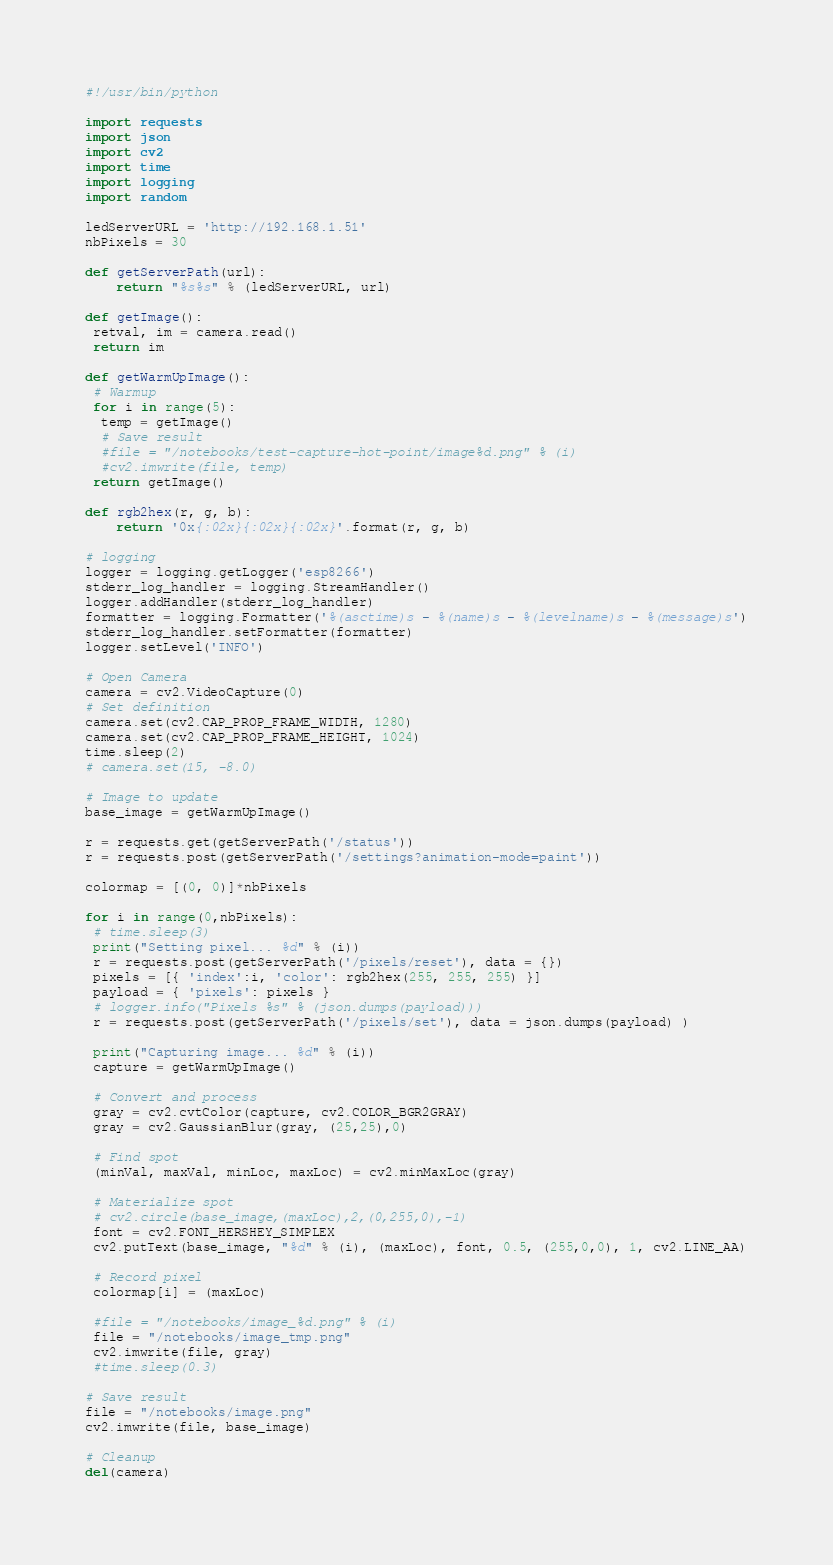<code> <loc_0><loc_0><loc_500><loc_500><_Python_>#!/usr/bin/python

import requests
import json
import cv2
import time
import logging
import random

ledServerURL = 'http://192.168.1.51'
nbPixels = 30

def getServerPath(url):
    return "%s%s" % (ledServerURL, url)

def getImage():
 retval, im = camera.read()
 return im

def getWarmUpImage():
 # Warmup
 for i in range(5):
  temp = getImage()
  # Save result
  #file = "/notebooks/test-capture-hot-point/image%d.png" % (i)
  #cv2.imwrite(file, temp)
 return getImage()

def rgb2hex(r, g, b):
    return '0x{:02x}{:02x}{:02x}'.format(r, g, b)

# logging
logger = logging.getLogger('esp8266')
stderr_log_handler = logging.StreamHandler()
logger.addHandler(stderr_log_handler)
formatter = logging.Formatter('%(asctime)s - %(name)s - %(levelname)s - %(message)s')
stderr_log_handler.setFormatter(formatter)
logger.setLevel('INFO')

# Open Camera
camera = cv2.VideoCapture(0)
# Set definition
camera.set(cv2.CAP_PROP_FRAME_WIDTH, 1280)
camera.set(cv2.CAP_PROP_FRAME_HEIGHT, 1024)
time.sleep(2)
# camera.set(15, -8.0)

# Image to update
base_image = getWarmUpImage()

r = requests.get(getServerPath('/status'))
r = requests.post(getServerPath('/settings?animation-mode=paint'))

colormap = [(0, 0)]*nbPixels

for i in range(0,nbPixels):
 # time.sleep(3)
 print("Setting pixel... %d" % (i))
 r = requests.post(getServerPath('/pixels/reset'), data = {})
 pixels = [{ 'index':i, 'color': rgb2hex(255, 255, 255) }]
 payload = { 'pixels': pixels }
 # logger.info("Pixels %s" % (json.dumps(payload)))
 r = requests.post(getServerPath('/pixels/set'), data = json.dumps(payload) )

 print("Capturing image... %d" % (i))
 capture = getWarmUpImage()
 
 # Convert and process
 gray = cv2.cvtColor(capture, cv2.COLOR_BGR2GRAY)
 gray = cv2.GaussianBlur(gray, (25,25),0)

 # Find spot
 (minVal, maxVal, minLoc, maxLoc) = cv2.minMaxLoc(gray)

 # Materialize spot
 # cv2.circle(base_image,(maxLoc),2,(0,255,0),-1)
 font = cv2.FONT_HERSHEY_SIMPLEX
 cv2.putText(base_image, "%d" % (i), (maxLoc), font, 0.5, (255,0,0), 1, cv2.LINE_AA)

 # Record pixel
 colormap[i] = (maxLoc)

 #file = "/notebooks/image_%d.png" % (i)
 file = "/notebooks/image_tmp.png"
 cv2.imwrite(file, gray)
 #time.sleep(0.3)

# Save result
file = "/notebooks/image.png"
cv2.imwrite(file, base_image)

# Cleanup
del(camera)
</code> 